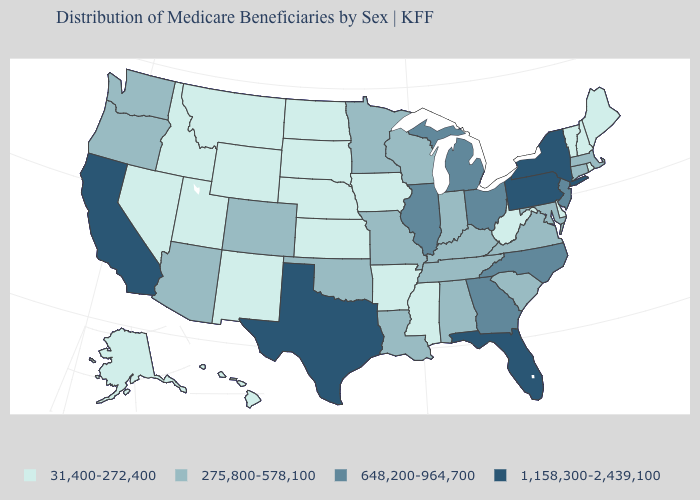Does Illinois have the lowest value in the MidWest?
Short answer required. No. What is the value of Arizona?
Write a very short answer. 275,800-578,100. What is the value of Virginia?
Write a very short answer. 275,800-578,100. Is the legend a continuous bar?
Be succinct. No. What is the value of Tennessee?
Write a very short answer. 275,800-578,100. Among the states that border Louisiana , does Arkansas have the lowest value?
Answer briefly. Yes. Name the states that have a value in the range 648,200-964,700?
Keep it brief. Georgia, Illinois, Michigan, New Jersey, North Carolina, Ohio. Which states hav the highest value in the MidWest?
Concise answer only. Illinois, Michigan, Ohio. Does the map have missing data?
Keep it brief. No. Name the states that have a value in the range 31,400-272,400?
Write a very short answer. Alaska, Arkansas, Delaware, Hawaii, Idaho, Iowa, Kansas, Maine, Mississippi, Montana, Nebraska, Nevada, New Hampshire, New Mexico, North Dakota, Rhode Island, South Dakota, Utah, Vermont, West Virginia, Wyoming. Does New York have the highest value in the USA?
Be succinct. Yes. Name the states that have a value in the range 31,400-272,400?
Give a very brief answer. Alaska, Arkansas, Delaware, Hawaii, Idaho, Iowa, Kansas, Maine, Mississippi, Montana, Nebraska, Nevada, New Hampshire, New Mexico, North Dakota, Rhode Island, South Dakota, Utah, Vermont, West Virginia, Wyoming. Among the states that border Texas , does Louisiana have the lowest value?
Short answer required. No. What is the value of New York?
Write a very short answer. 1,158,300-2,439,100. What is the value of New York?
Keep it brief. 1,158,300-2,439,100. 